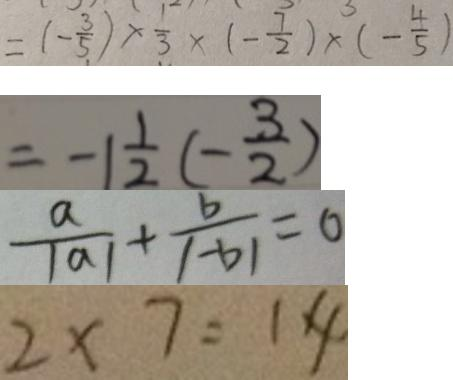<formula> <loc_0><loc_0><loc_500><loc_500>= ( - \frac { 3 } { 5 } ) \times \frac { 1 } { 3 } \times ( - \frac { 7 } { 2 } ) \times ( - \frac { 4 } { 5 } ) 
 = - 1 \frac { 1 } { 2 } ( - \frac { 3 } { 2 } ) 
 \frac { a } { \vert a \vert } + \frac { b } { \vert - b \vert } = 0 
 2 \times 7 = 1 4</formula> 